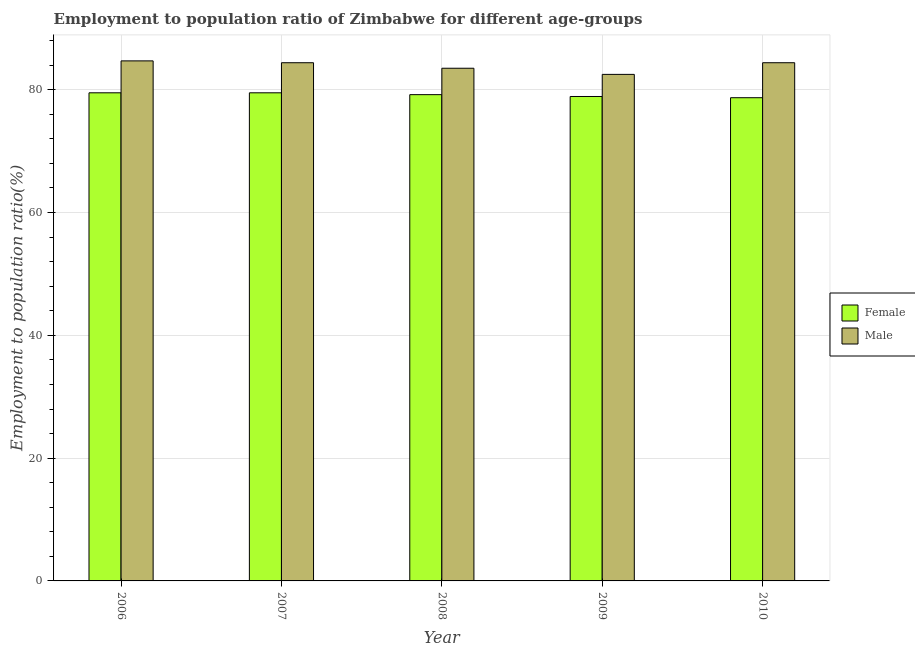How many bars are there on the 2nd tick from the right?
Your response must be concise. 2. What is the label of the 1st group of bars from the left?
Keep it short and to the point. 2006. What is the employment to population ratio(female) in 2006?
Keep it short and to the point. 79.5. Across all years, what is the maximum employment to population ratio(female)?
Make the answer very short. 79.5. Across all years, what is the minimum employment to population ratio(male)?
Your response must be concise. 82.5. In which year was the employment to population ratio(male) maximum?
Ensure brevity in your answer.  2006. In which year was the employment to population ratio(male) minimum?
Make the answer very short. 2009. What is the total employment to population ratio(male) in the graph?
Provide a succinct answer. 419.5. What is the difference between the employment to population ratio(female) in 2009 and that in 2010?
Give a very brief answer. 0.2. What is the difference between the employment to population ratio(male) in 2009 and the employment to population ratio(female) in 2007?
Your answer should be compact. -1.9. What is the average employment to population ratio(male) per year?
Ensure brevity in your answer.  83.9. In the year 2007, what is the difference between the employment to population ratio(male) and employment to population ratio(female)?
Provide a succinct answer. 0. In how many years, is the employment to population ratio(male) greater than 28 %?
Offer a terse response. 5. What is the ratio of the employment to population ratio(female) in 2006 to that in 2009?
Offer a terse response. 1.01. What is the difference between the highest and the second highest employment to population ratio(female)?
Your answer should be compact. 0. What is the difference between the highest and the lowest employment to population ratio(female)?
Provide a succinct answer. 0.8. In how many years, is the employment to population ratio(male) greater than the average employment to population ratio(male) taken over all years?
Offer a very short reply. 3. What does the 2nd bar from the left in 2010 represents?
Offer a terse response. Male. What does the 1st bar from the right in 2006 represents?
Provide a short and direct response. Male. How many bars are there?
Provide a short and direct response. 10. Are all the bars in the graph horizontal?
Provide a short and direct response. No. How many years are there in the graph?
Give a very brief answer. 5. What is the difference between two consecutive major ticks on the Y-axis?
Your answer should be compact. 20. Does the graph contain grids?
Offer a very short reply. Yes. Where does the legend appear in the graph?
Give a very brief answer. Center right. How many legend labels are there?
Make the answer very short. 2. How are the legend labels stacked?
Make the answer very short. Vertical. What is the title of the graph?
Provide a succinct answer. Employment to population ratio of Zimbabwe for different age-groups. What is the label or title of the X-axis?
Offer a terse response. Year. What is the label or title of the Y-axis?
Keep it short and to the point. Employment to population ratio(%). What is the Employment to population ratio(%) in Female in 2006?
Keep it short and to the point. 79.5. What is the Employment to population ratio(%) in Male in 2006?
Your answer should be very brief. 84.7. What is the Employment to population ratio(%) in Female in 2007?
Offer a terse response. 79.5. What is the Employment to population ratio(%) of Male in 2007?
Your response must be concise. 84.4. What is the Employment to population ratio(%) in Female in 2008?
Make the answer very short. 79.2. What is the Employment to population ratio(%) of Male in 2008?
Make the answer very short. 83.5. What is the Employment to population ratio(%) of Female in 2009?
Your answer should be compact. 78.9. What is the Employment to population ratio(%) of Male in 2009?
Provide a short and direct response. 82.5. What is the Employment to population ratio(%) in Female in 2010?
Ensure brevity in your answer.  78.7. What is the Employment to population ratio(%) in Male in 2010?
Make the answer very short. 84.4. Across all years, what is the maximum Employment to population ratio(%) in Female?
Give a very brief answer. 79.5. Across all years, what is the maximum Employment to population ratio(%) in Male?
Offer a very short reply. 84.7. Across all years, what is the minimum Employment to population ratio(%) in Female?
Give a very brief answer. 78.7. Across all years, what is the minimum Employment to population ratio(%) in Male?
Provide a succinct answer. 82.5. What is the total Employment to population ratio(%) in Female in the graph?
Offer a very short reply. 395.8. What is the total Employment to population ratio(%) in Male in the graph?
Provide a short and direct response. 419.5. What is the difference between the Employment to population ratio(%) of Female in 2006 and that in 2007?
Give a very brief answer. 0. What is the difference between the Employment to population ratio(%) in Female in 2006 and that in 2008?
Your answer should be very brief. 0.3. What is the difference between the Employment to population ratio(%) of Female in 2006 and that in 2009?
Offer a terse response. 0.6. What is the difference between the Employment to population ratio(%) in Male in 2006 and that in 2009?
Your answer should be compact. 2.2. What is the difference between the Employment to population ratio(%) of Female in 2006 and that in 2010?
Make the answer very short. 0.8. What is the difference between the Employment to population ratio(%) of Male in 2007 and that in 2008?
Your response must be concise. 0.9. What is the difference between the Employment to population ratio(%) of Female in 2007 and that in 2009?
Offer a very short reply. 0.6. What is the difference between the Employment to population ratio(%) of Female in 2007 and that in 2010?
Keep it short and to the point. 0.8. What is the difference between the Employment to population ratio(%) in Female in 2008 and that in 2009?
Keep it short and to the point. 0.3. What is the difference between the Employment to population ratio(%) of Male in 2008 and that in 2010?
Give a very brief answer. -0.9. What is the difference between the Employment to population ratio(%) of Female in 2009 and that in 2010?
Your answer should be very brief. 0.2. What is the difference between the Employment to population ratio(%) of Male in 2009 and that in 2010?
Your answer should be very brief. -1.9. What is the difference between the Employment to population ratio(%) of Female in 2006 and the Employment to population ratio(%) of Male in 2008?
Keep it short and to the point. -4. What is the difference between the Employment to population ratio(%) of Female in 2006 and the Employment to population ratio(%) of Male in 2010?
Your answer should be compact. -4.9. What is the difference between the Employment to population ratio(%) of Female in 2007 and the Employment to population ratio(%) of Male in 2008?
Your answer should be very brief. -4. What is the difference between the Employment to population ratio(%) of Female in 2007 and the Employment to population ratio(%) of Male in 2010?
Your answer should be very brief. -4.9. What is the difference between the Employment to population ratio(%) of Female in 2008 and the Employment to population ratio(%) of Male in 2010?
Provide a succinct answer. -5.2. What is the difference between the Employment to population ratio(%) of Female in 2009 and the Employment to population ratio(%) of Male in 2010?
Ensure brevity in your answer.  -5.5. What is the average Employment to population ratio(%) of Female per year?
Provide a succinct answer. 79.16. What is the average Employment to population ratio(%) in Male per year?
Provide a short and direct response. 83.9. In the year 2006, what is the difference between the Employment to population ratio(%) in Female and Employment to population ratio(%) in Male?
Provide a succinct answer. -5.2. In the year 2009, what is the difference between the Employment to population ratio(%) of Female and Employment to population ratio(%) of Male?
Give a very brief answer. -3.6. What is the ratio of the Employment to population ratio(%) in Male in 2006 to that in 2008?
Offer a terse response. 1.01. What is the ratio of the Employment to population ratio(%) in Female in 2006 to that in 2009?
Your answer should be very brief. 1.01. What is the ratio of the Employment to population ratio(%) of Male in 2006 to that in 2009?
Offer a very short reply. 1.03. What is the ratio of the Employment to population ratio(%) in Female in 2006 to that in 2010?
Offer a very short reply. 1.01. What is the ratio of the Employment to population ratio(%) of Male in 2006 to that in 2010?
Your response must be concise. 1. What is the ratio of the Employment to population ratio(%) in Male in 2007 to that in 2008?
Provide a succinct answer. 1.01. What is the ratio of the Employment to population ratio(%) of Female in 2007 to that in 2009?
Provide a succinct answer. 1.01. What is the ratio of the Employment to population ratio(%) of Female in 2007 to that in 2010?
Ensure brevity in your answer.  1.01. What is the ratio of the Employment to population ratio(%) of Male in 2008 to that in 2009?
Give a very brief answer. 1.01. What is the ratio of the Employment to population ratio(%) in Female in 2008 to that in 2010?
Offer a very short reply. 1.01. What is the ratio of the Employment to population ratio(%) in Male in 2008 to that in 2010?
Make the answer very short. 0.99. What is the ratio of the Employment to population ratio(%) of Male in 2009 to that in 2010?
Your response must be concise. 0.98. What is the difference between the highest and the second highest Employment to population ratio(%) of Male?
Your response must be concise. 0.3. What is the difference between the highest and the lowest Employment to population ratio(%) in Female?
Provide a succinct answer. 0.8. 